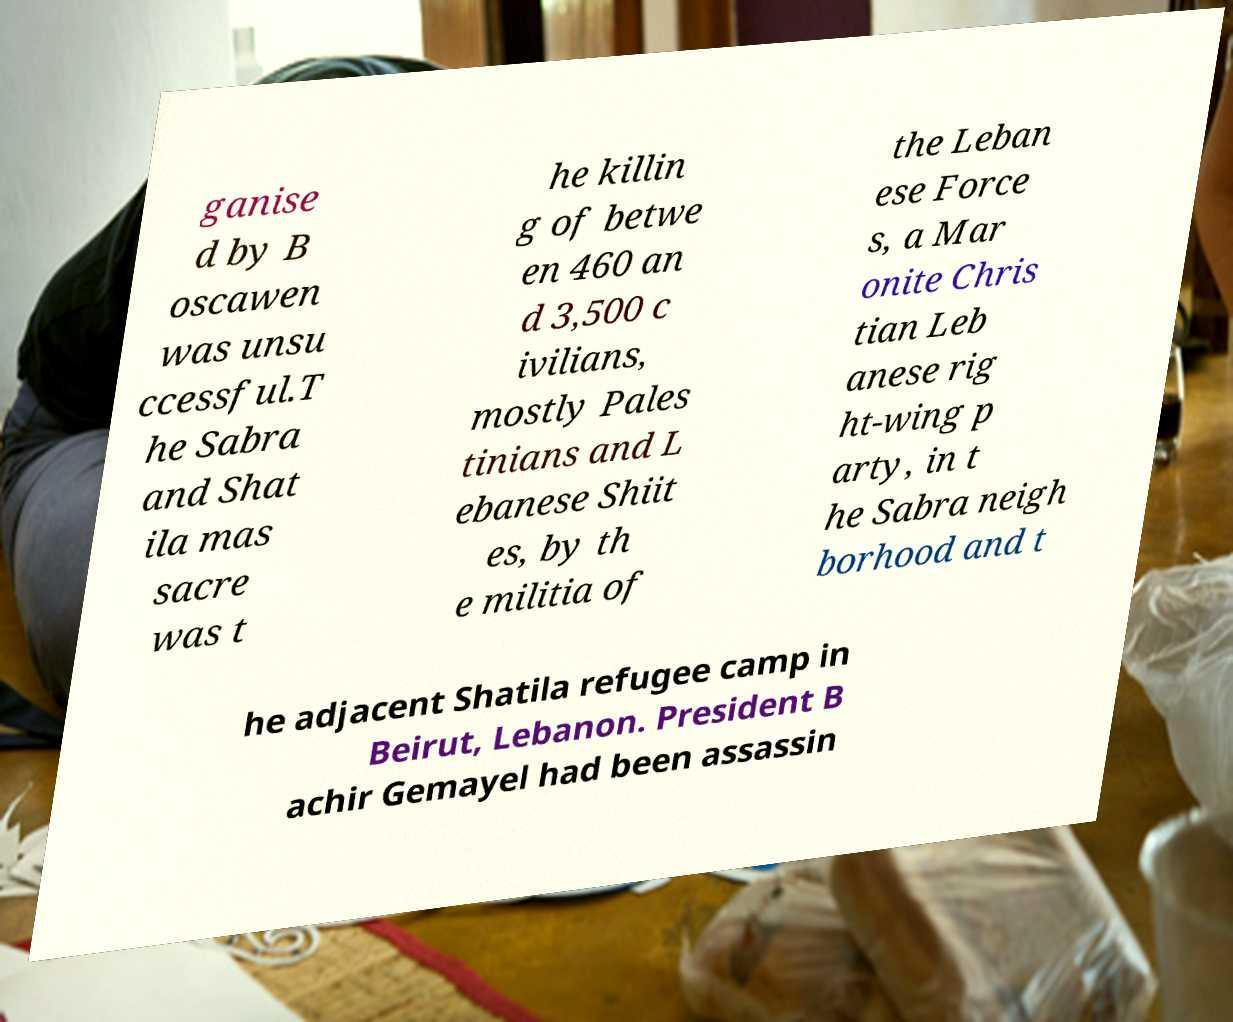For documentation purposes, I need the text within this image transcribed. Could you provide that? ganise d by B oscawen was unsu ccessful.T he Sabra and Shat ila mas sacre was t he killin g of betwe en 460 an d 3,500 c ivilians, mostly Pales tinians and L ebanese Shiit es, by th e militia of the Leban ese Force s, a Mar onite Chris tian Leb anese rig ht-wing p arty, in t he Sabra neigh borhood and t he adjacent Shatila refugee camp in Beirut, Lebanon. President B achir Gemayel had been assassin 